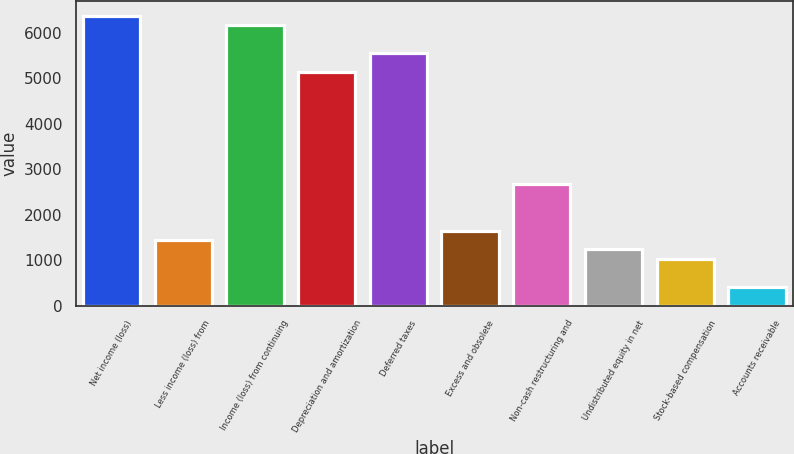Convert chart. <chart><loc_0><loc_0><loc_500><loc_500><bar_chart><fcel>Net income (loss)<fcel>Less income (loss) from<fcel>Income (loss) from continuing<fcel>Depreciation and amortization<fcel>Deferred taxes<fcel>Excess and obsolete<fcel>Non-cash restructuring and<fcel>Undistributed equity in net<fcel>Stock-based compensation<fcel>Accounts receivable<nl><fcel>6375.6<fcel>1441.2<fcel>6170<fcel>5142<fcel>5553.2<fcel>1646.8<fcel>2674.8<fcel>1235.6<fcel>1030<fcel>413.2<nl></chart> 